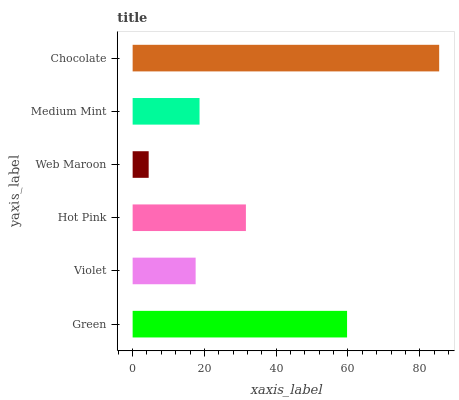Is Web Maroon the minimum?
Answer yes or no. Yes. Is Chocolate the maximum?
Answer yes or no. Yes. Is Violet the minimum?
Answer yes or no. No. Is Violet the maximum?
Answer yes or no. No. Is Green greater than Violet?
Answer yes or no. Yes. Is Violet less than Green?
Answer yes or no. Yes. Is Violet greater than Green?
Answer yes or no. No. Is Green less than Violet?
Answer yes or no. No. Is Hot Pink the high median?
Answer yes or no. Yes. Is Medium Mint the low median?
Answer yes or no. Yes. Is Violet the high median?
Answer yes or no. No. Is Web Maroon the low median?
Answer yes or no. No. 